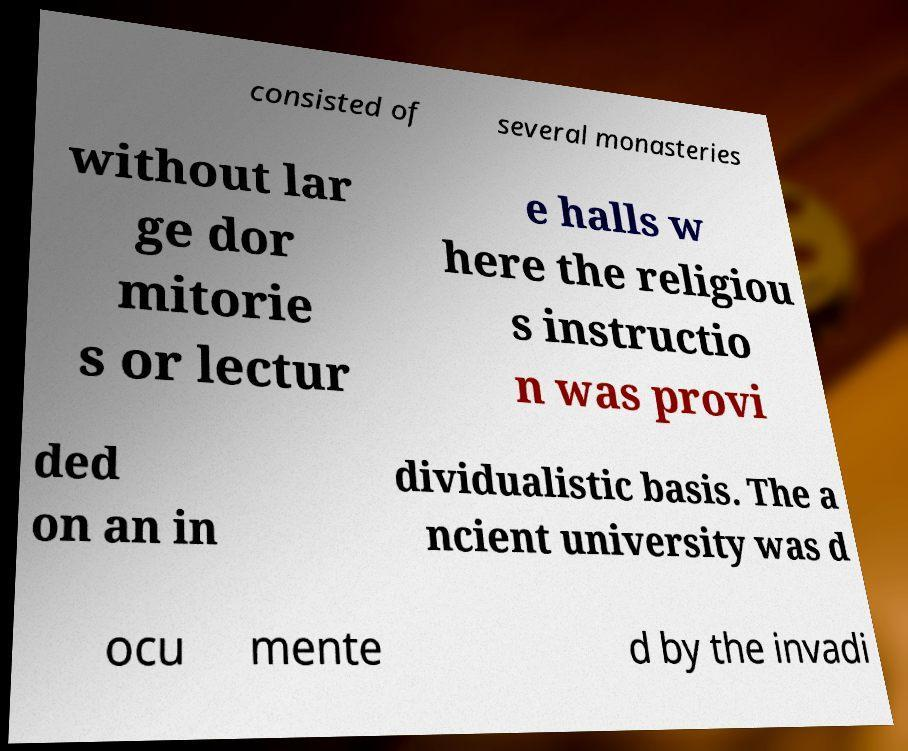Please identify and transcribe the text found in this image. consisted of several monasteries without lar ge dor mitorie s or lectur e halls w here the religiou s instructio n was provi ded on an in dividualistic basis. The a ncient university was d ocu mente d by the invadi 